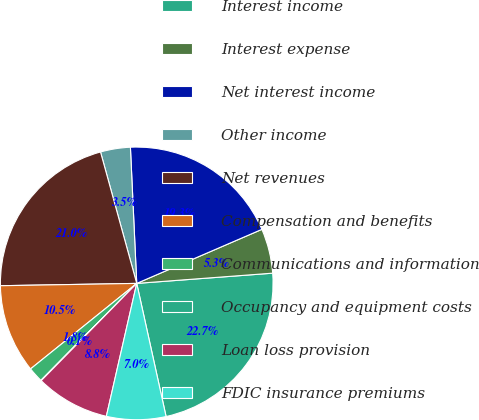Convert chart. <chart><loc_0><loc_0><loc_500><loc_500><pie_chart><fcel>Interest income<fcel>Interest expense<fcel>Net interest income<fcel>Other income<fcel>Net revenues<fcel>Compensation and benefits<fcel>Communications and information<fcel>Occupancy and equipment costs<fcel>Loan loss provision<fcel>FDIC insurance premiums<nl><fcel>22.74%<fcel>5.29%<fcel>19.25%<fcel>3.54%<fcel>20.99%<fcel>10.52%<fcel>1.8%<fcel>0.05%<fcel>8.78%<fcel>7.03%<nl></chart> 